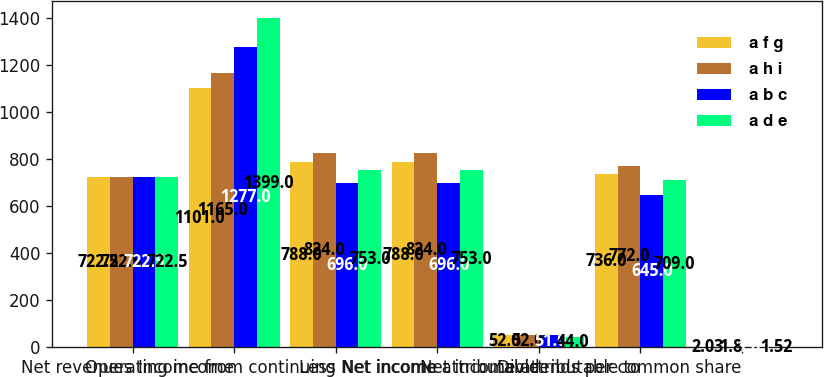Convert chart. <chart><loc_0><loc_0><loc_500><loc_500><stacked_bar_chart><ecel><fcel>Net revenues<fcel>Operating income<fcel>Income from continuing<fcel>Net income<fcel>Less Net income attributable<fcel>Net income attributable to<fcel>Dividends per common share<nl><fcel>a f g<fcel>722.5<fcel>1101<fcel>788<fcel>788<fcel>52<fcel>736<fcel>2.03<nl><fcel>a h i<fcel>722.5<fcel>1165<fcel>824<fcel>824<fcel>52<fcel>772<fcel>1.8<nl><fcel>a b c<fcel>722.5<fcel>1277<fcel>696<fcel>696<fcel>51<fcel>645<fcel>1.65<nl><fcel>a d e<fcel>722.5<fcel>1399<fcel>753<fcel>753<fcel>44<fcel>709<fcel>1.52<nl></chart> 